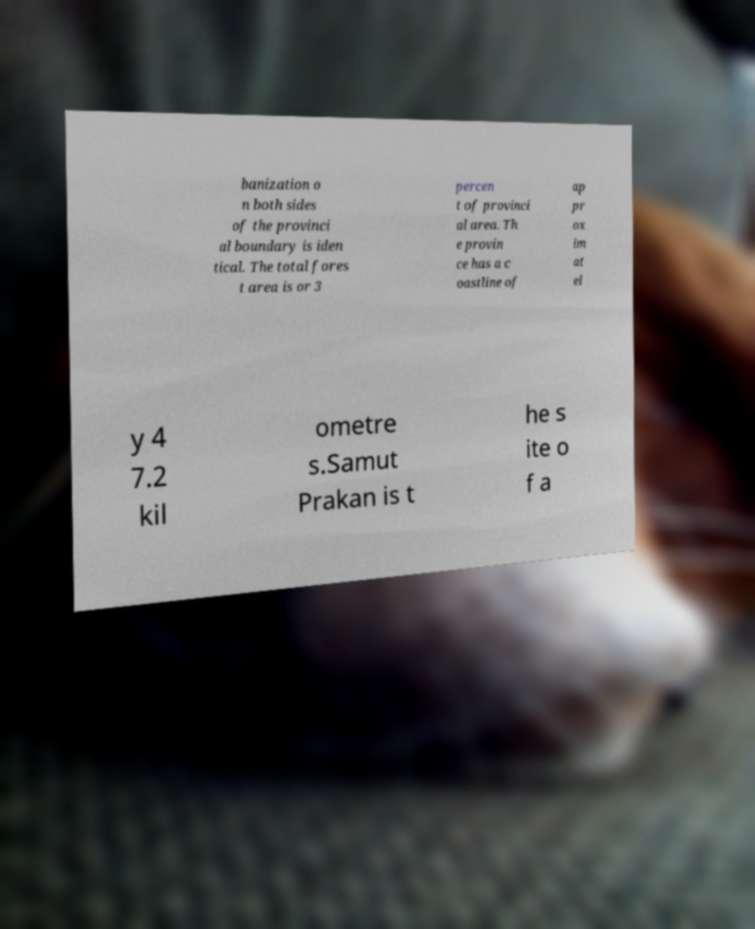Please identify and transcribe the text found in this image. banization o n both sides of the provinci al boundary is iden tical. The total fores t area is or 3 percen t of provinci al area. Th e provin ce has a c oastline of ap pr ox im at el y 4 7.2 kil ometre s.Samut Prakan is t he s ite o f a 